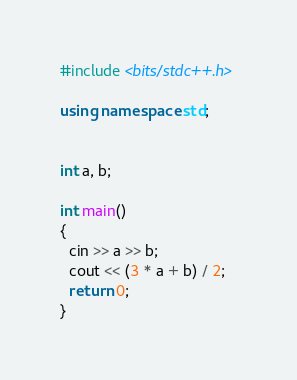Convert code to text. <code><loc_0><loc_0><loc_500><loc_500><_C++_>#include <bits/stdc++.h>

using namespace std;


int a, b;

int main()
{
  cin >> a >> b;
  cout << (3 * a + b) / 2;
  return 0;
}
</code> 